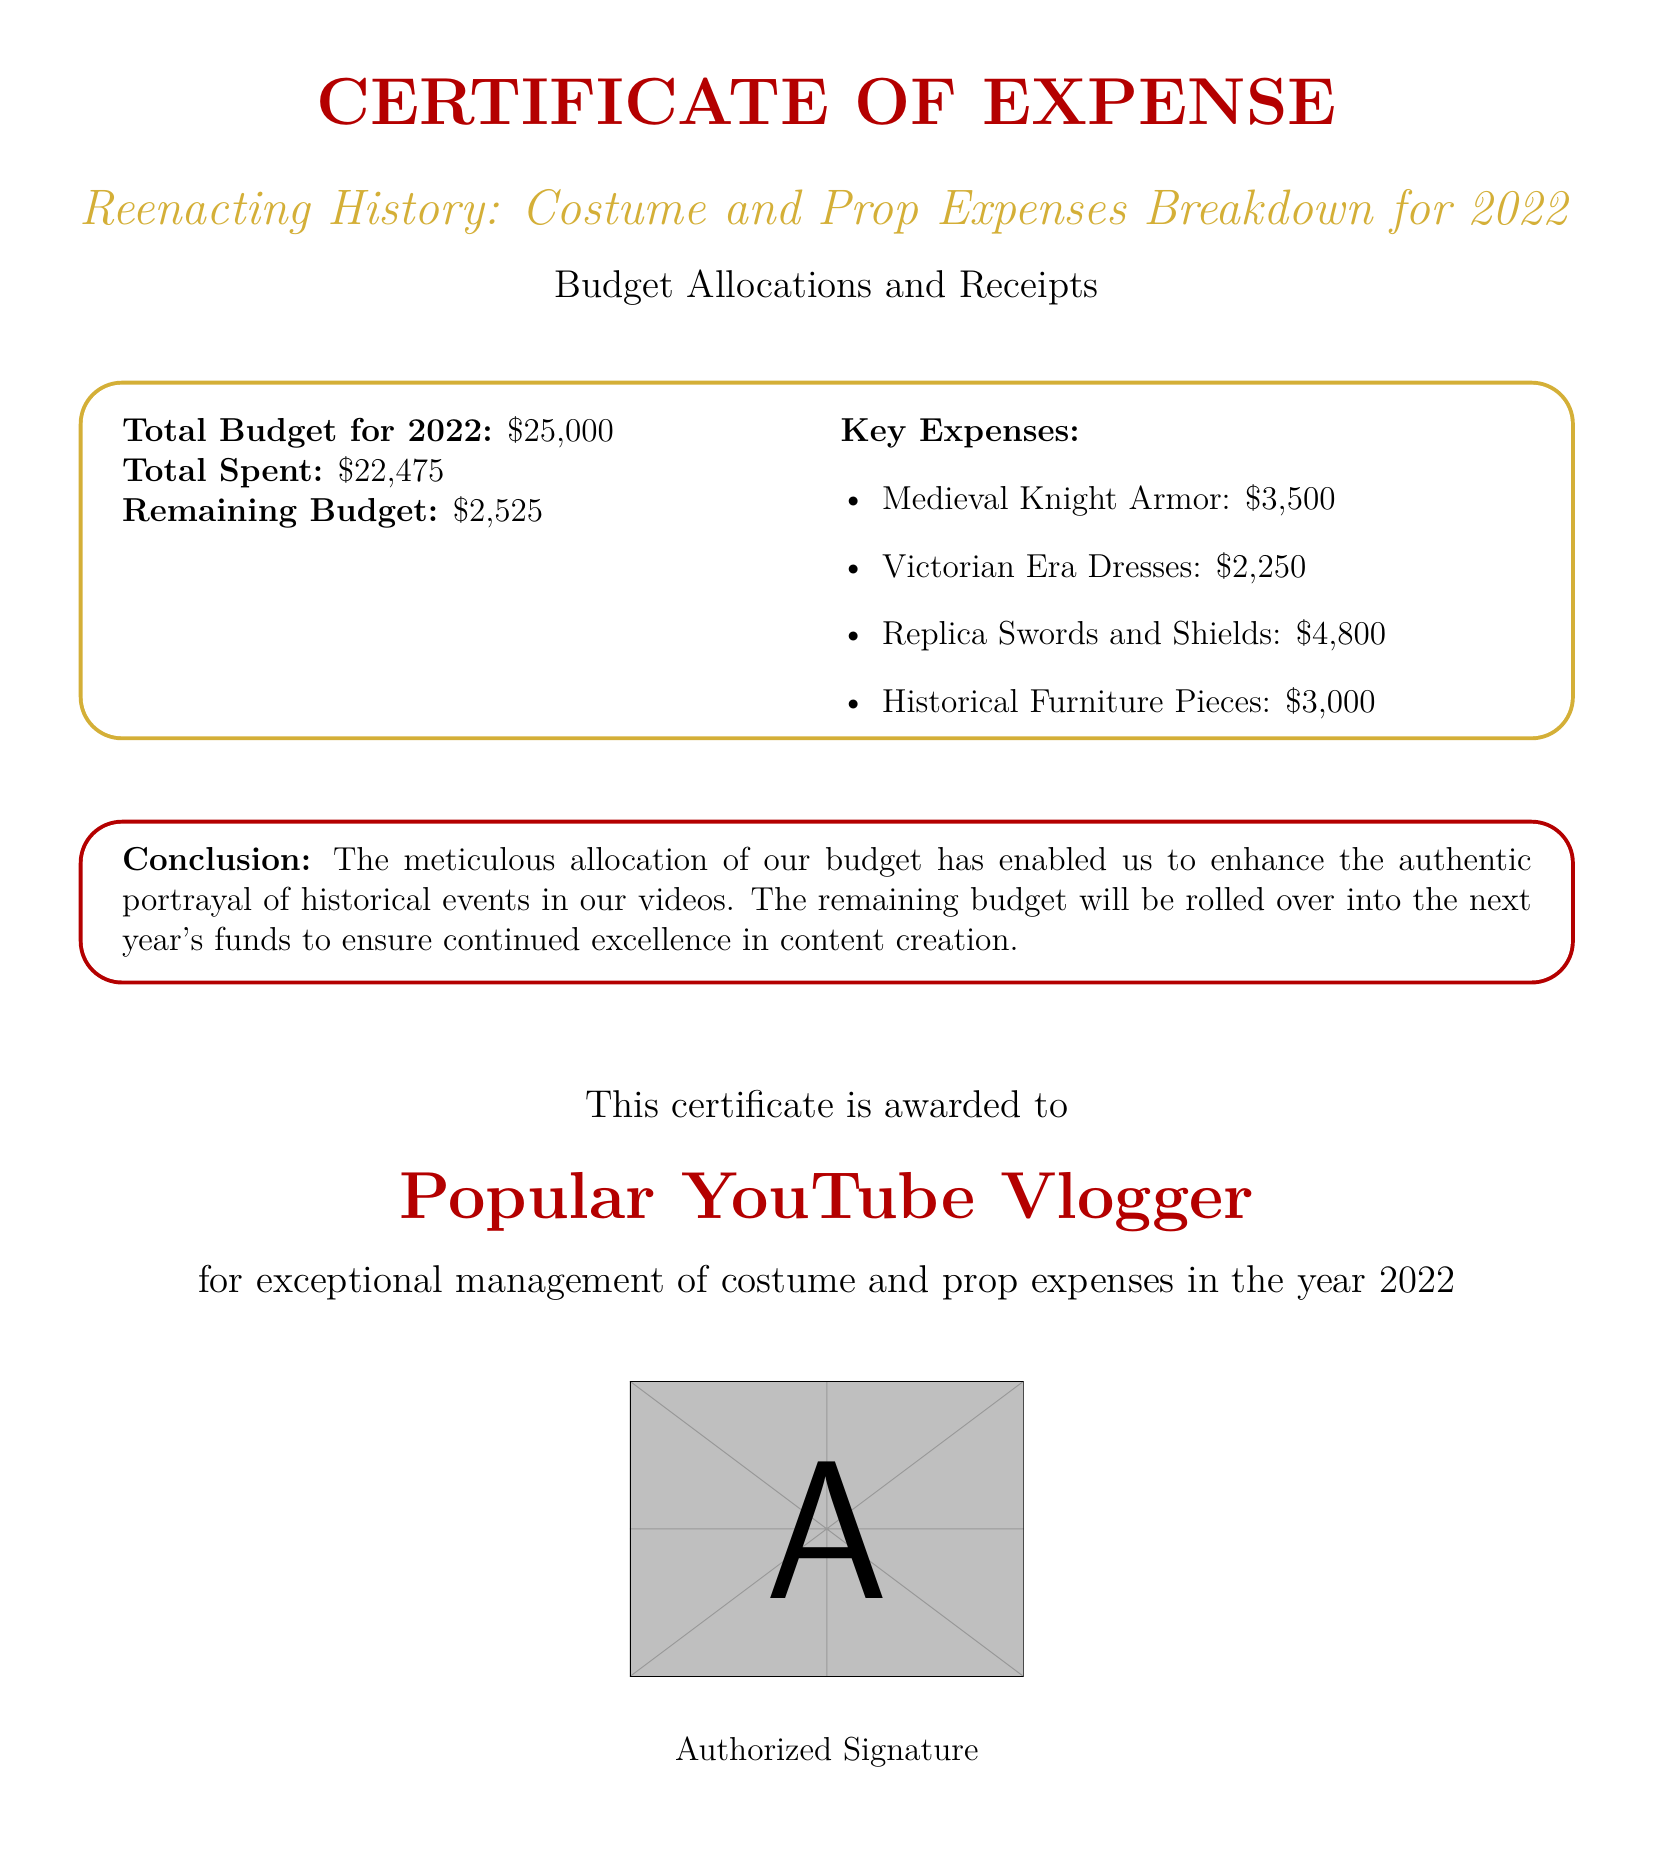what is the total budget for 2022? The total budget for 2022 is explicitly stated in the document as $25,000.
Answer: $25,000 how much was spent in total? The document specifies the total amount spent as $22,475.
Answer: $22,475 what is the remaining budget? The remaining budget is calculated by subtracting the total spent from the total budget, which is $2,525.
Answer: $2,525 what was the cost of medieval knight armor? The document lists medieval knight armor expenses as $3,500.
Answer: $3,500 which expense category had the highest allocation? By comparing the key expenses listed in the document, the highest expense is replica swords and shields at $4,800.
Answer: Replica Swords and Shields what is the purpose of the remaining budget? The document states that the remaining budget will be rolled over into the next year's funds to ensure continued excellence in content creation.
Answer: Rolled over into next year's funds what document type is this? The structure and content indicate that this is a Certificate of Expense related to budget management.
Answer: Certificate of Expense who is awarded this certificate? The award is given to "Popular YouTube Vlogger" as specified in the document.
Answer: Popular YouTube Vlogger what was the total spent on Victorian era dresses? The total expense for Victorian Era Dresses is clearly indicated in the document as $2,250.
Answer: $2,250 